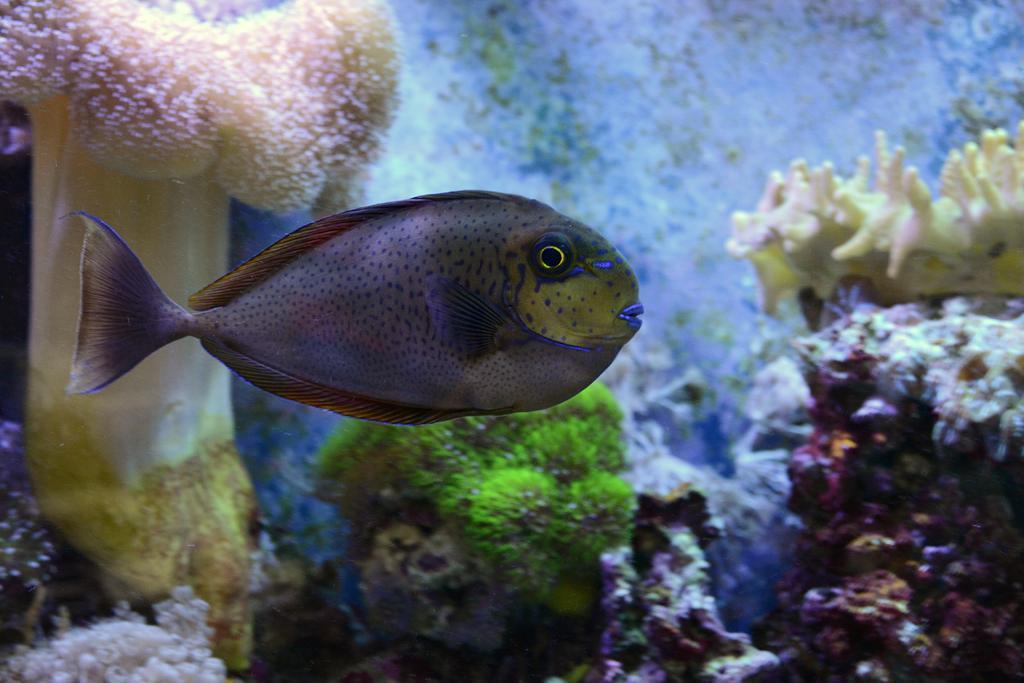Describe this image in one or two sentences. This is a zoomed in picture. In the center there is a fish swimming in the water body. In the background we can see the marine creatures and marine plants. 